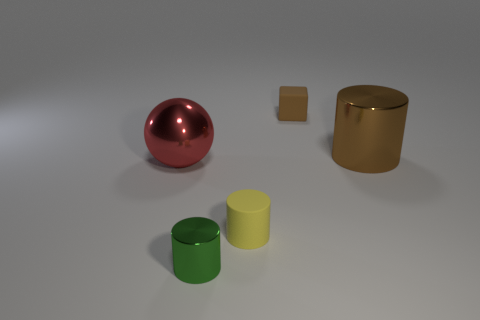There is a big object that is the same shape as the tiny green thing; what is it made of?
Your answer should be very brief. Metal. Is there any other thing that is made of the same material as the big ball?
Offer a very short reply. Yes. Does the cylinder that is behind the red metallic sphere have the same material as the tiny green thing that is in front of the big red shiny object?
Your response must be concise. Yes. There is a large shiny thing left of the big thing to the right of the matte thing that is behind the red metal thing; what color is it?
Your answer should be compact. Red. What number of other objects are there of the same shape as the large red object?
Make the answer very short. 0. Is the color of the metal sphere the same as the rubber cylinder?
Provide a succinct answer. No. What number of things are either purple metal spheres or things in front of the brown cube?
Ensure brevity in your answer.  4. Is there another green shiny thing that has the same size as the green shiny thing?
Offer a terse response. No. Are the tiny brown thing and the brown cylinder made of the same material?
Keep it short and to the point. No. How many things are brown metal things or small green cubes?
Your answer should be compact. 1. 